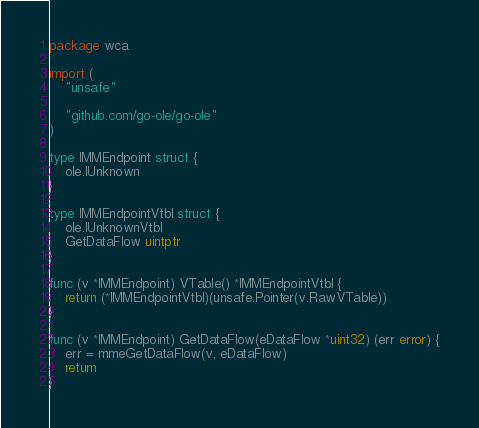Convert code to text. <code><loc_0><loc_0><loc_500><loc_500><_Go_>package wca

import (
	"unsafe"

	"github.com/go-ole/go-ole"
)

type IMMEndpoint struct {
	ole.IUnknown
}

type IMMEndpointVtbl struct {
	ole.IUnknownVtbl
	GetDataFlow uintptr
}

func (v *IMMEndpoint) VTable() *IMMEndpointVtbl {
	return (*IMMEndpointVtbl)(unsafe.Pointer(v.RawVTable))
}

func (v *IMMEndpoint) GetDataFlow(eDataFlow *uint32) (err error) {
	err = mmeGetDataFlow(v, eDataFlow)
	return
}
</code> 